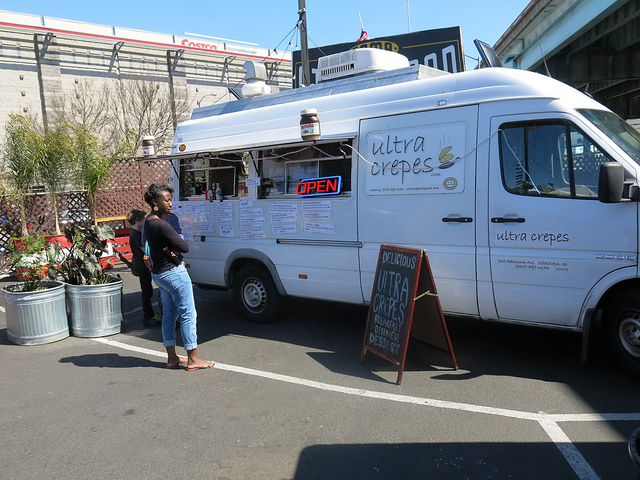Can you tell me about the environment surrounding the food truck? The food truck is stationed in a sunny outdoor area, with clear skies above. There's an organized and inviting setup with potted plants near the service window, and it’s parked on what looks like a street or a designated area for food trucks, potentially part of a larger market or outdoor event space. 